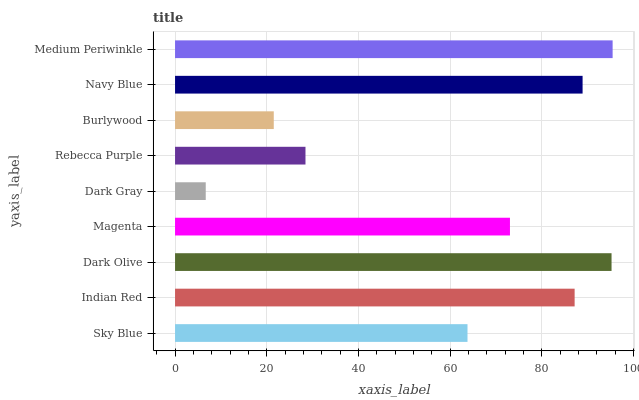Is Dark Gray the minimum?
Answer yes or no. Yes. Is Medium Periwinkle the maximum?
Answer yes or no. Yes. Is Indian Red the minimum?
Answer yes or no. No. Is Indian Red the maximum?
Answer yes or no. No. Is Indian Red greater than Sky Blue?
Answer yes or no. Yes. Is Sky Blue less than Indian Red?
Answer yes or no. Yes. Is Sky Blue greater than Indian Red?
Answer yes or no. No. Is Indian Red less than Sky Blue?
Answer yes or no. No. Is Magenta the high median?
Answer yes or no. Yes. Is Magenta the low median?
Answer yes or no. Yes. Is Indian Red the high median?
Answer yes or no. No. Is Indian Red the low median?
Answer yes or no. No. 